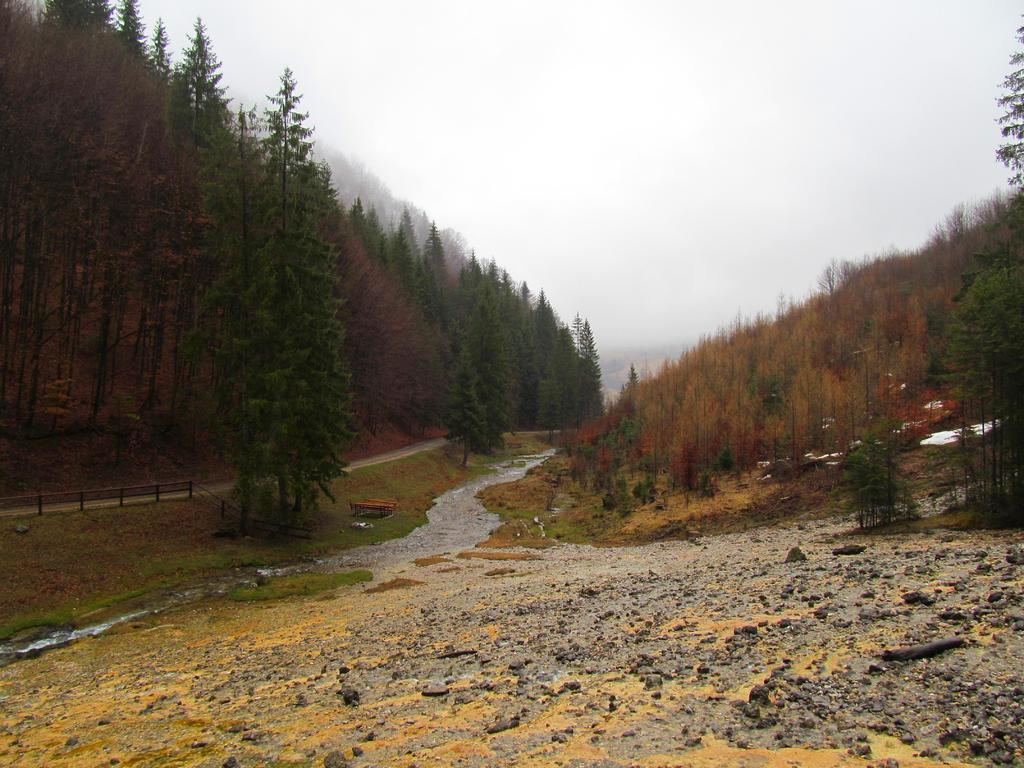What type of natural landform can be seen in the image? There are mountains in the image. What type of vegetation is present in the image? There are trees and plants in the image. What type of man-made structures can be seen in the image? There are fences in the image. What type of natural feature can be seen in the image? There is water visible in the image. What else can be seen in the image besides the mentioned elements? There are other objects in the image. What is visible in the background of the image? The sky is visible in the background of the image. Where is the chicken located in the image? There is no chicken present in the image. Can you see any icicles hanging from the trees in the image? There are no icicles visible in the image; it appears to be a warm or temperate environment. Is there an oven visible in the image? There is no oven present in the image. 